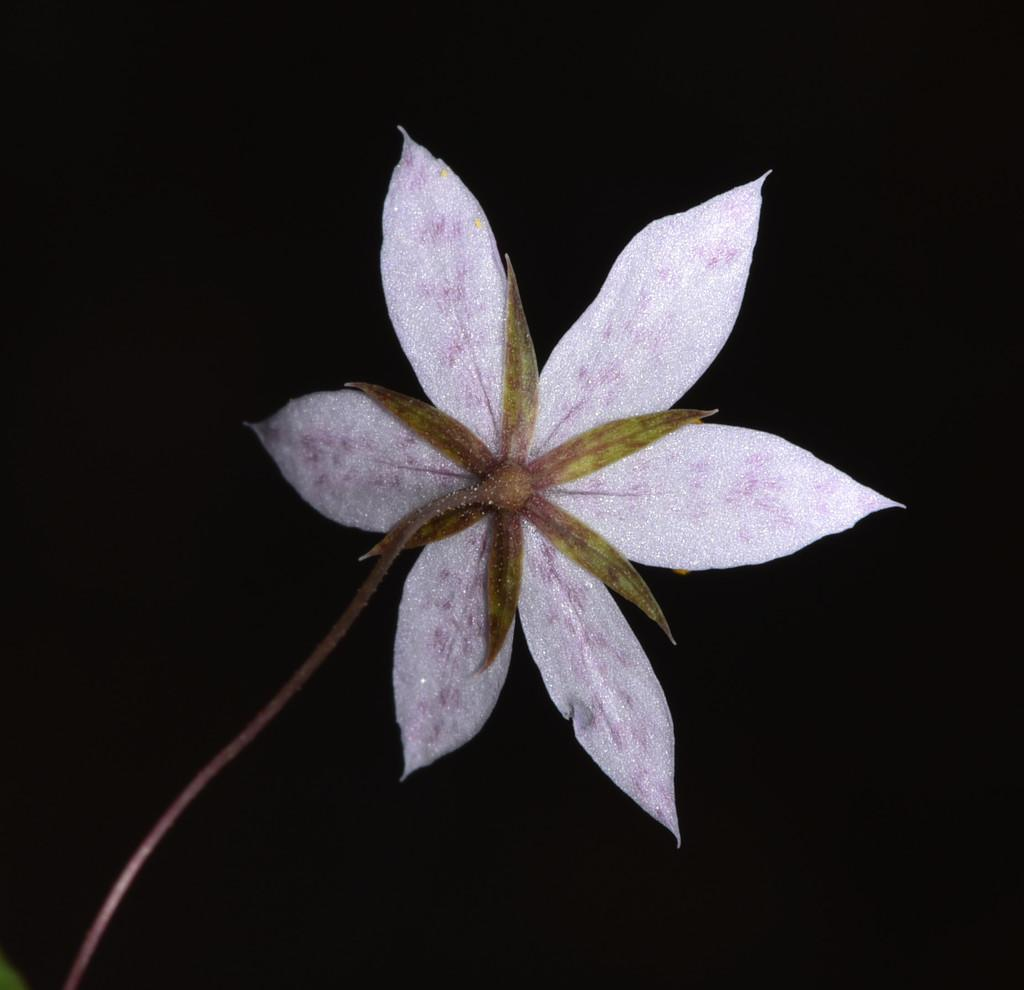What is the main subject of the image? There is a flower in the image. Can you describe the flower's features? The flower has petals and a stem. What color is the flower? The flower is light pink in color. How would you describe the background of the image? The background of the image is dark. How many hydrants are visible in the image? There are no hydrants present in the image. What type of light is being used to illuminate the flower in the image? The image does not show any artificial light source; the flower's color is described as light pink, which suggests natural light. 